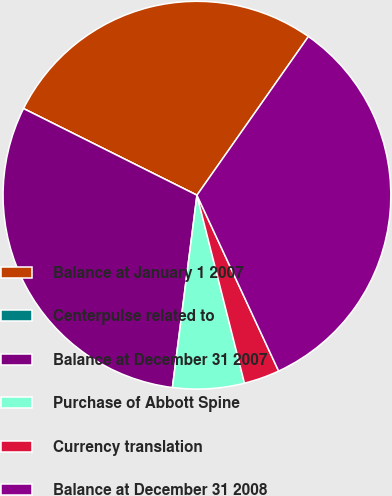Convert chart to OTSL. <chart><loc_0><loc_0><loc_500><loc_500><pie_chart><fcel>Balance at January 1 2007<fcel>Centerpulse related to<fcel>Balance at December 31 2007<fcel>Purchase of Abbott Spine<fcel>Currency translation<fcel>Balance at December 31 2008<nl><fcel>27.37%<fcel>0.0%<fcel>30.35%<fcel>5.96%<fcel>2.98%<fcel>33.33%<nl></chart> 